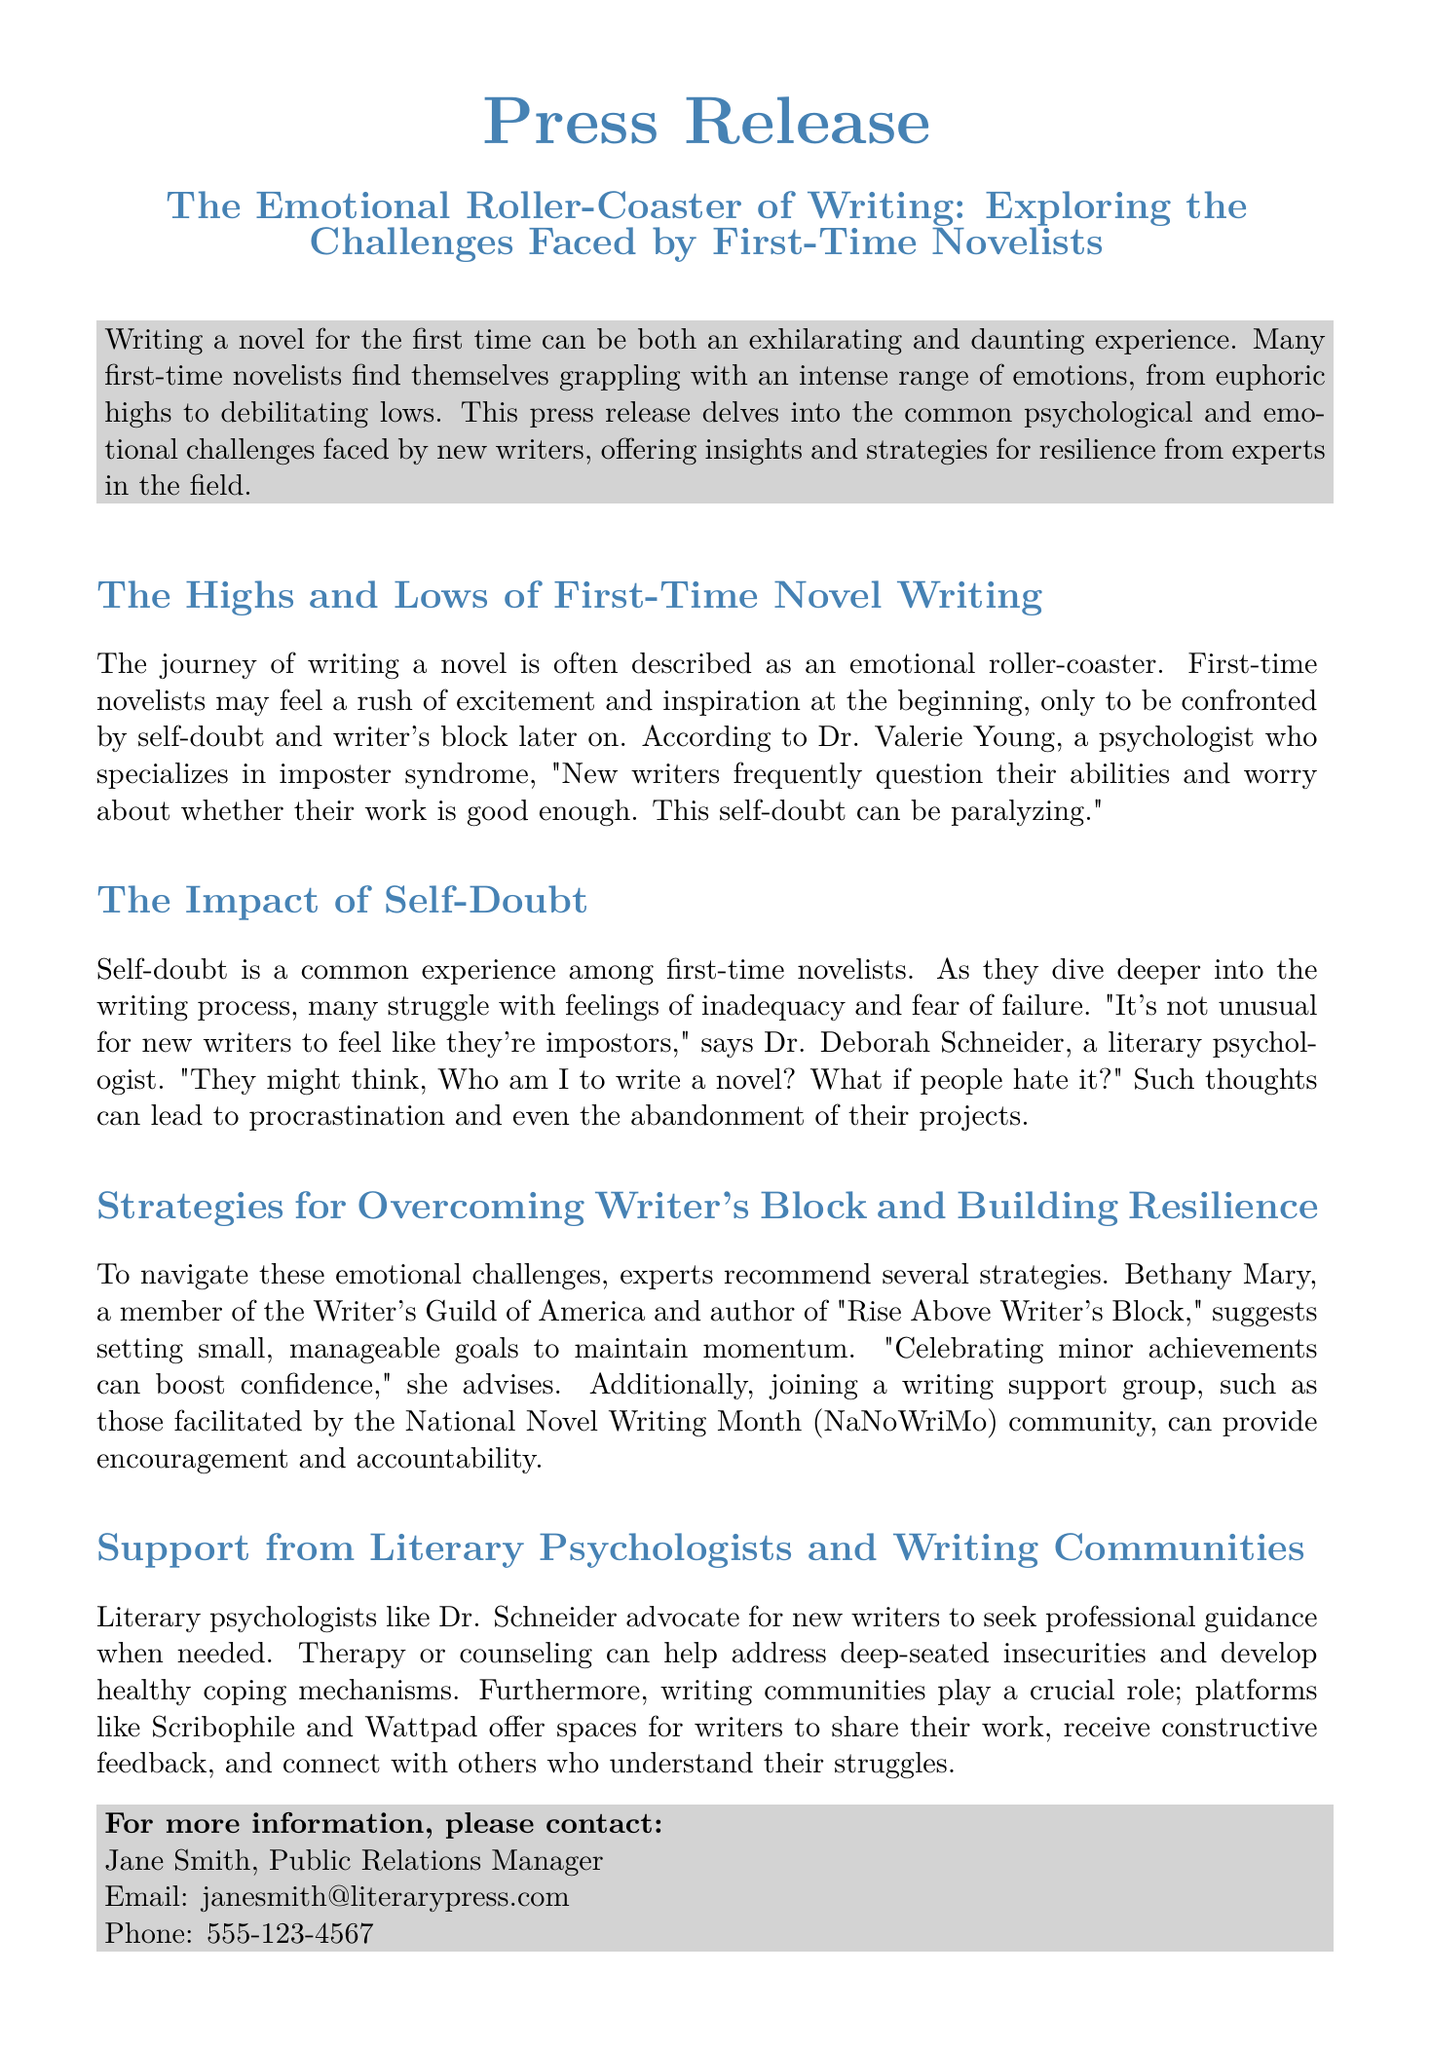What is the title of the press release? The title of the press release is stated at the top of the document.
Answer: The Emotional Roller-Coaster of Writing: Exploring the Challenges Faced by First-Time Novelists Who is Dr. Valerie Young? Dr. Valerie Young is mentioned as a psychologist specializing in imposter syndrome in the document.
Answer: A psychologist What is the main emotional challenge faced by first-time novelists? The document highlights self-doubt as a major emotional challenge for new writers.
Answer: Self-doubt What strategy does Bethany Mary recommend for overcoming writer's block? Bethany Mary suggests a specific method for writers to maintain momentum in their writing process.
Answer: Setting small, manageable goals What platforms are mentioned as writing communities? The document lists platforms that help writers share their work and connect with others.
Answer: Scribophile and Wattpad What role do literary psychologists play according to Dr. Schneider? Dr. Schneider emphasizes the importance of guidance from literary psychologists for new writers.
Answer: Professional guidance How should new writers celebrate achievements according to the press release? The press release suggests a way for writers to boost their confidence after achieving goals.
Answer: Celebrating minor achievements 